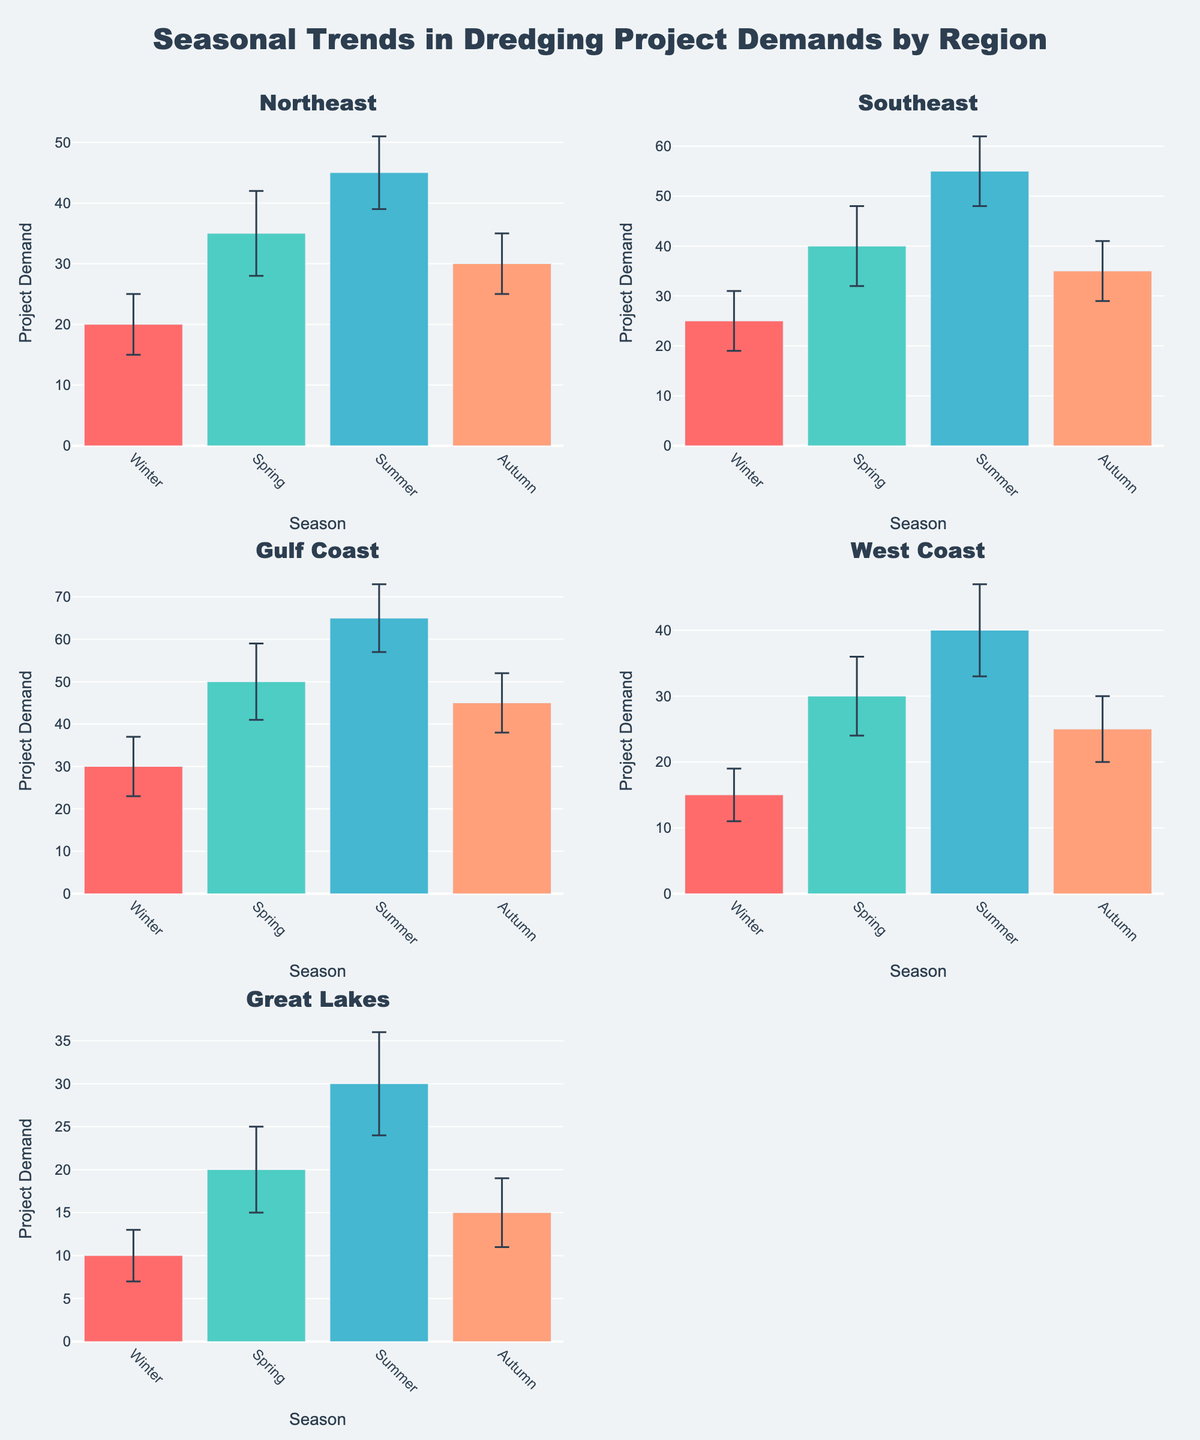What's the title of the figure? The title is usually located at the top of the figure. In this case, it states the subject and data focus, which is "Seasonal Trends in Dredging Project Demands by Region".
Answer: Seasonal Trends in Dredging Project Demands by Region Which region has the highest average project demand across all seasons? To find this, calculate the average project demand for each region by summing the project demands for all seasons and then dividing by the number of seasons. Comparing these averages gives us the region with the highest value. Northeast: (20+35+45+30)/4=32.5, Southeast: (25+40+55+35)/4=38.75, Gulf Coast: (30+50+65+45)/4=47.5, West Coast: (15+30+40+25)/4=27.5, Great Lakes: (10+20+30+15)/4=18.75. The Gulf Coast has the highest average.
Answer: Gulf Coast How does the winter project demand in the Northeast compare to the Southeast? Locate the winter project demand values for both regions: Northeast has a demand of 20, and Southeast has a demand of 25. Comparison shows that the Southeast has a higher winter project demand than the Northeast.
Answer: Southeast has higher demand In which season does the Gulf Coast have the lowest project demand, and what is that demand? Look for the lowest bar in the Gulf Coast subplot. The lowest project demand is in Winter with a value of 30.
Answer: Winter, 30 What is the difference in Summer project demands between the Northeast and West Coast regions? Identify the Summer project demands for Northeast (45) and West Coast (40). Subtract to find the difference: 45 - 40 = 5.
Answer: 5 How does the error margin for Summer in the West Coast compare to Spring in the Great Lakes? Refer to the error bars for each specific season and region. Summer in the West Coast has an error margin of 7, while Spring in the Great Lakes has an error margin of 5. Hence, Summer in the West Coast has a higher error margin.
Answer: West Coast has higher margin Which region shows the largest seasonal variation in project demand, and what are those demands? Check the difference between the highest and lowest project demands for each region. Gulf Coast shows the greatest variation with Summer at 65 and Winter at 30 (a difference of 35).
Answer: Gulf Coast, demands are 65 in Summer and 30 in Winter What is the combined project demand for all regions in Autumn? Add project demands from all regions for Autumn: Northeast (30), Southeast (35), Gulf Coast (45), West Coast (25), Great Lakes (15). Thus, 30 + 35 + 45 + 25 + 15 = 150.
Answer: 150 Is there any season where the project demands are generally high across all regions? Examine project demands across all seasons for all regions to see if there is a consistent trend. Summer appears to generally have higher demands across all regions.
Answer: Summer 